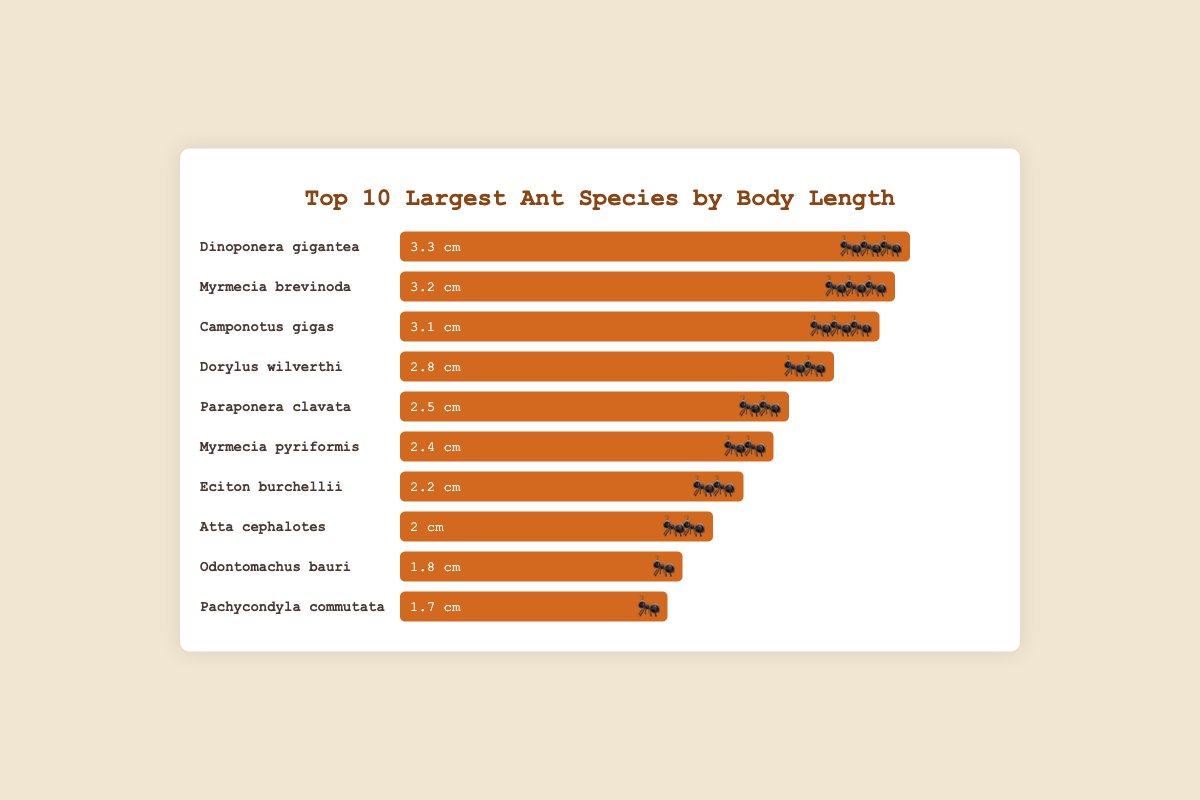What is the title of the figure? The title is typically displayed at the top of the figure. Here, it is displayed within the `h1` tag, reading "Top 10 Largest Ant Species by Body Length".
Answer: Top 10 Largest Ant Species by Body Length Which ant species is the longest according to the chart? By observing the top row (as patterns are often sorted), "Dinoponera gigantea" is identified as the longest ant with a body length of 3.3 cm.
Answer: Dinoponera gigantea How long is the ant species "Myrmecia pyriformis"? Locate "Myrmecia pyriformis" in the list and check the associated bar label, which shows a length of 2.4 cm.
Answer: 2.4 cm Which ant species has the smallest emoji in the figure? Identify the species with the smallest emoji, represented with a sign of "🐜". "Odontomachus bauri" and "Pachycondyla commutata" are both denoted by this emoji.
Answer: Odontomachus bauri, Pachycondyla commutata What is the difference in body length between "Dinoponera gigantea" and "Dorylus wilverthi"? "Dinoponera gigantea" has a body length of 3.3 cm, and "Dorylus wilverthi" has 2.8 cm. Subtract 2.8 from 3.3 to find the difference: 3.3 - 2.8 = 0.5 cm.
Answer: 0.5 cm How many ant species have a body length of 3 cm or more? Count the species with body lengths 3 cm or longer: "Dinoponera gigantea" (3.3 cm), "Myrmecia brevinoda" (3.2 cm), and "Camponotus gigas" (3.1 cm), resulting in a total of three.
Answer: 3 Which ant is shorter, "Paraponera clavata" or "Eciton burchellii"? Compare lengths: "Paraponera clavata" is 2.5 cm, and "Eciton burchellii" is 2.2 cm. Therefore, "Eciton burchellii" is shorter.
Answer: Eciton burchellii What is the combined body length of "Atta cephalotes" and "Odontomachus bauri"? Adding the lengths: "Atta cephalotes" (2.0 cm) and "Odontomachus bauri" (1.8 cm), the combined length is: 2.0 + 1.8 = 3.8 cm.
Answer: 3.8 cm Which ant species with the body length less than 2.0 cm has the smallest emoji? Focus on species with less than 2.0 cm: "Odontomachus bauri" (1.8 cm) and "Pachycondyla commutata" (1.7 cm). Both use "🐜" emoji, indicating the smallest.
Answer: Odontomachus bauri, Pachycondyla commutata 